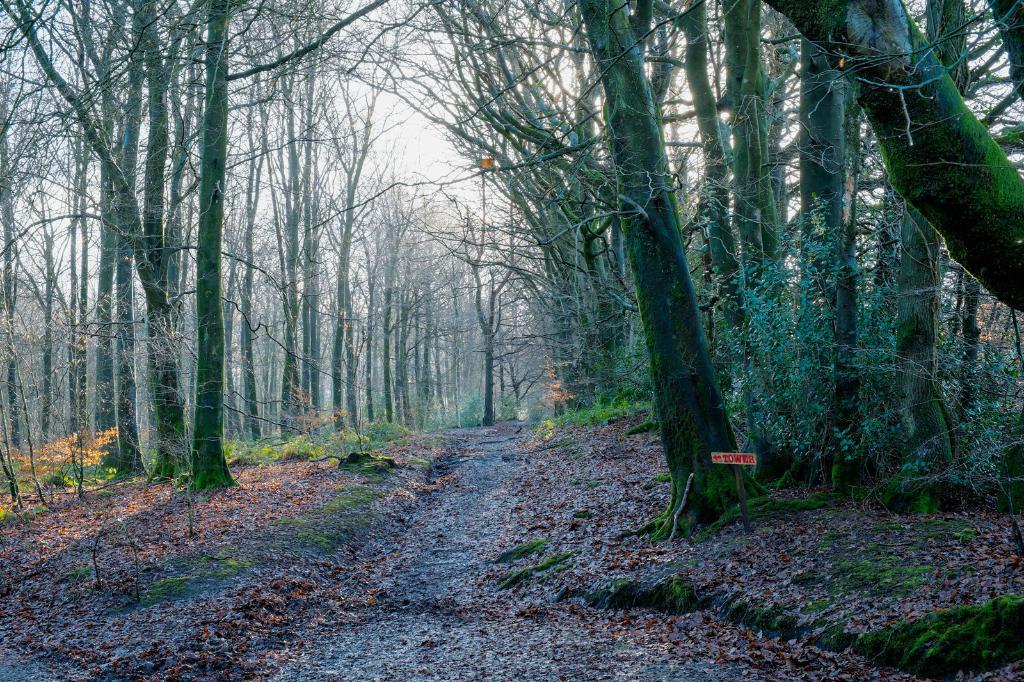What type of vegetation can be seen in the image? There are trees and plants in the image. What is covering the ground in the image? Dry leaves are present on the ground. What type of business is being conducted in the image? There is no indication of a business in the image; it primarily features trees, plants, and dry leaves on the ground. 